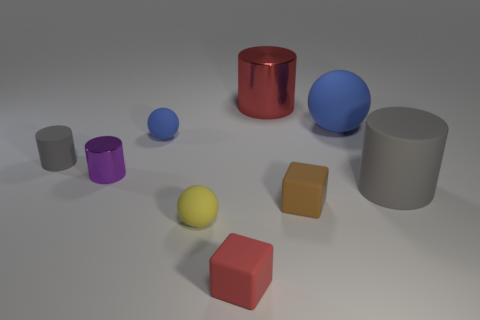How many tiny blue objects have the same shape as the yellow rubber object?
Offer a terse response. 1. What is the gray cylinder that is to the right of the tiny red object made of?
Your answer should be compact. Rubber. Do the gray matte thing that is to the right of the large ball and the tiny brown thing have the same shape?
Ensure brevity in your answer.  No. Is there a metal cylinder that has the same size as the brown matte block?
Offer a very short reply. Yes. Does the big red thing have the same shape as the big matte object in front of the tiny gray thing?
Give a very brief answer. Yes. The thing that is the same color as the big matte ball is what shape?
Your response must be concise. Sphere. Is the number of gray cylinders to the left of the brown block less than the number of gray rubber objects?
Make the answer very short. Yes. Do the tiny brown object and the small red thing have the same shape?
Your response must be concise. Yes. What is the size of the blue ball that is made of the same material as the tiny blue thing?
Provide a succinct answer. Large. Is the number of red spheres less than the number of tiny gray rubber objects?
Provide a succinct answer. Yes. 